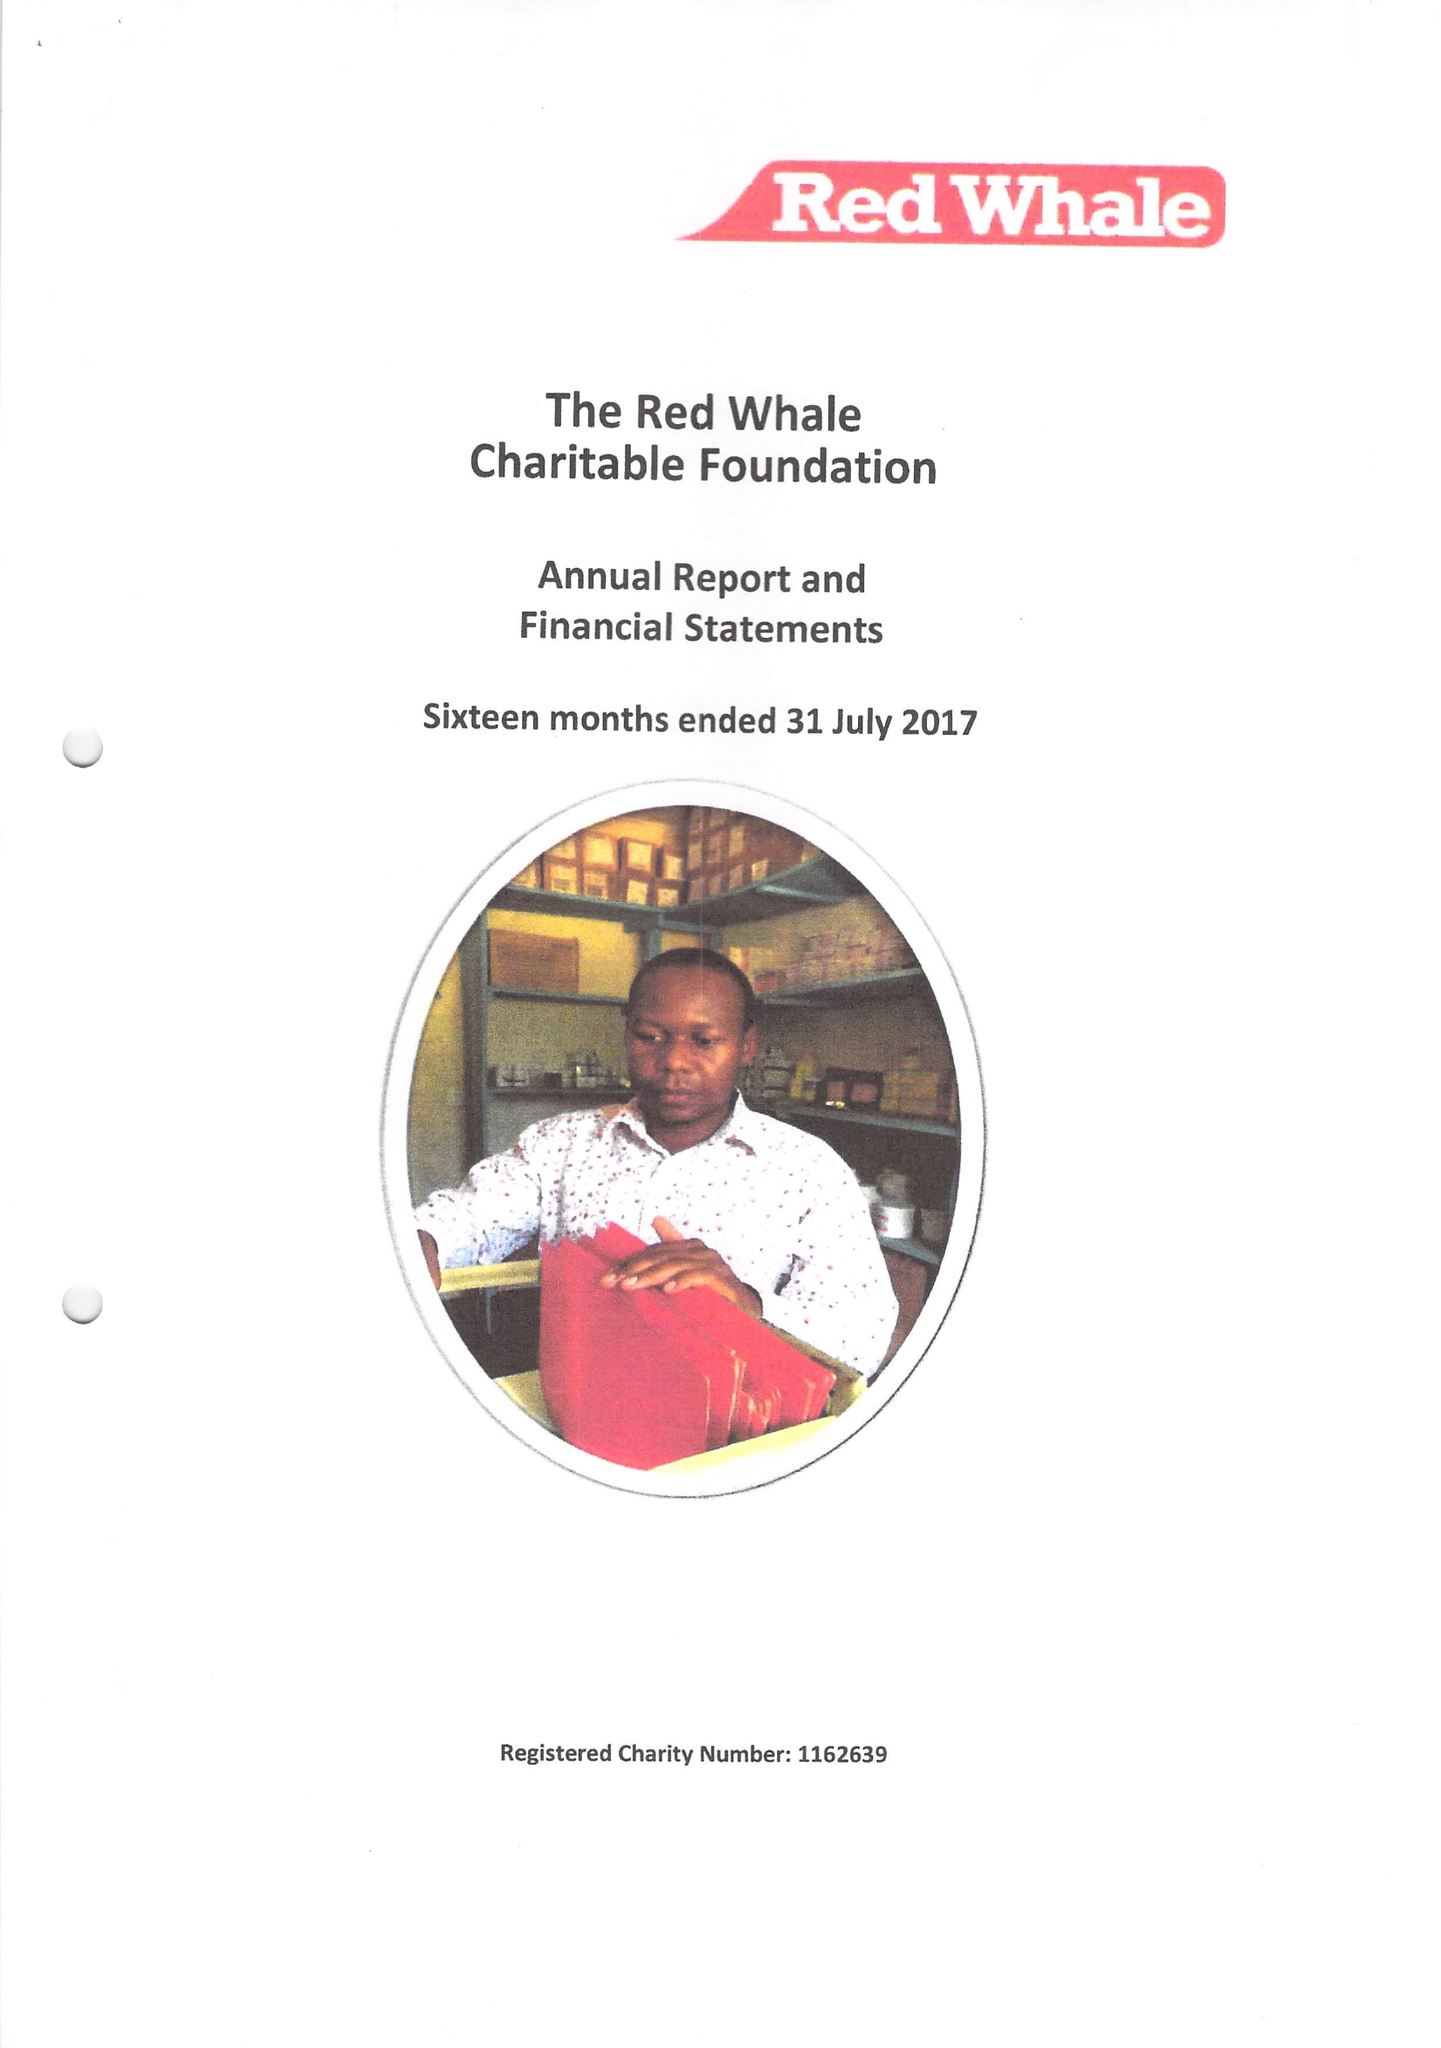What is the value for the address__post_town?
Answer the question using a single word or phrase. READING 